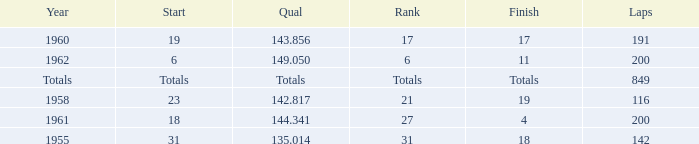What is the year with 116 laps? 1958.0. 